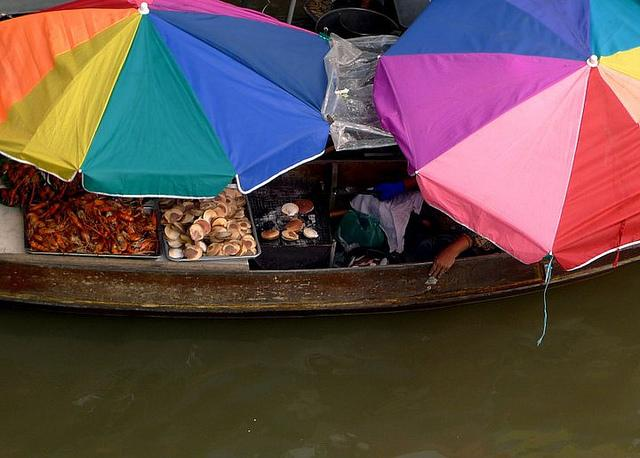What sort of food is being moved here?

Choices:
A) seafood
B) goat
C) chicken
D) beef seafood 